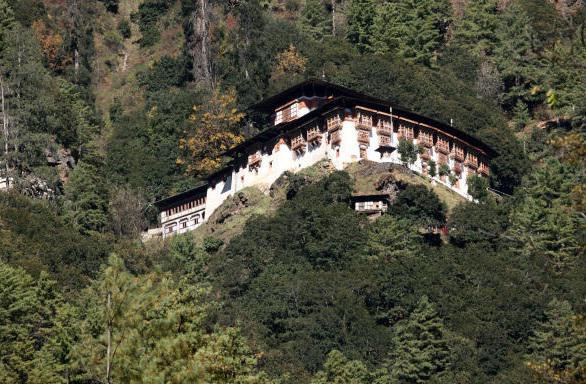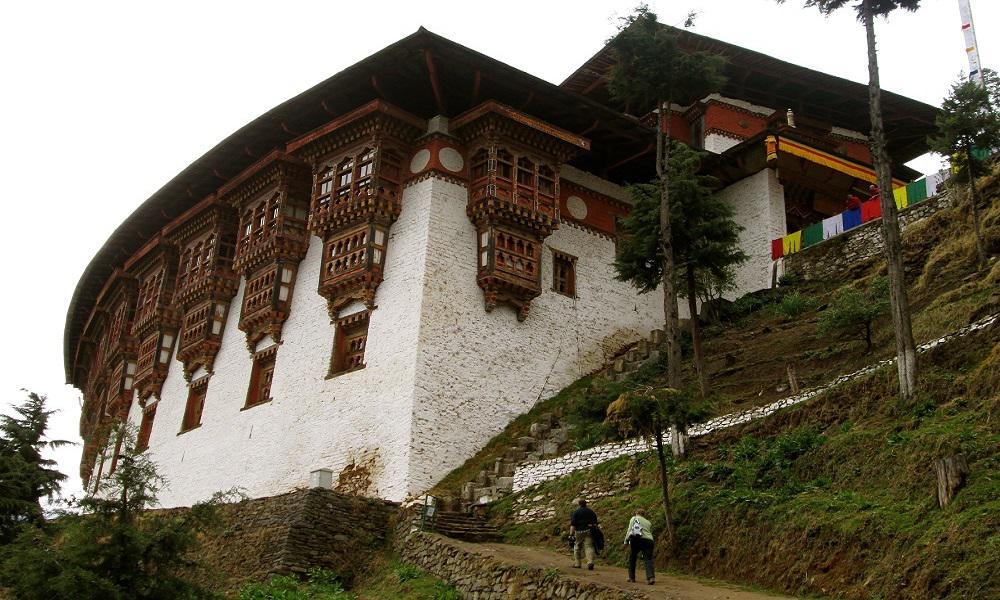The first image is the image on the left, the second image is the image on the right. Given the left and right images, does the statement "blue sky can be seen in the right pic" hold true? Answer yes or no. No. The first image is the image on the left, the second image is the image on the right. Examine the images to the left and right. Is the description "In at least one image there are people outside of a monastery." accurate? Answer yes or no. Yes. The first image is the image on the left, the second image is the image on the right. Evaluate the accuracy of this statement regarding the images: "An image shows multiple people in front of a hillside building.". Is it true? Answer yes or no. Yes. 